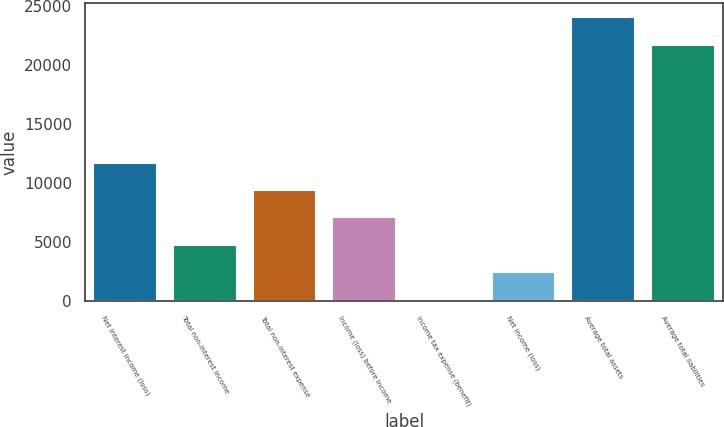<chart> <loc_0><loc_0><loc_500><loc_500><bar_chart><fcel>Net interest income (loss)<fcel>Total non-interest income<fcel>Total non-interest expense<fcel>Income (loss) before income<fcel>Income tax expense (benefit)<fcel>Net income (loss)<fcel>Average total assets<fcel>Average total liabilities<nl><fcel>11772.1<fcel>4795.98<fcel>9446.76<fcel>7121.37<fcel>145.2<fcel>2470.59<fcel>24086.5<fcel>21761.1<nl></chart> 